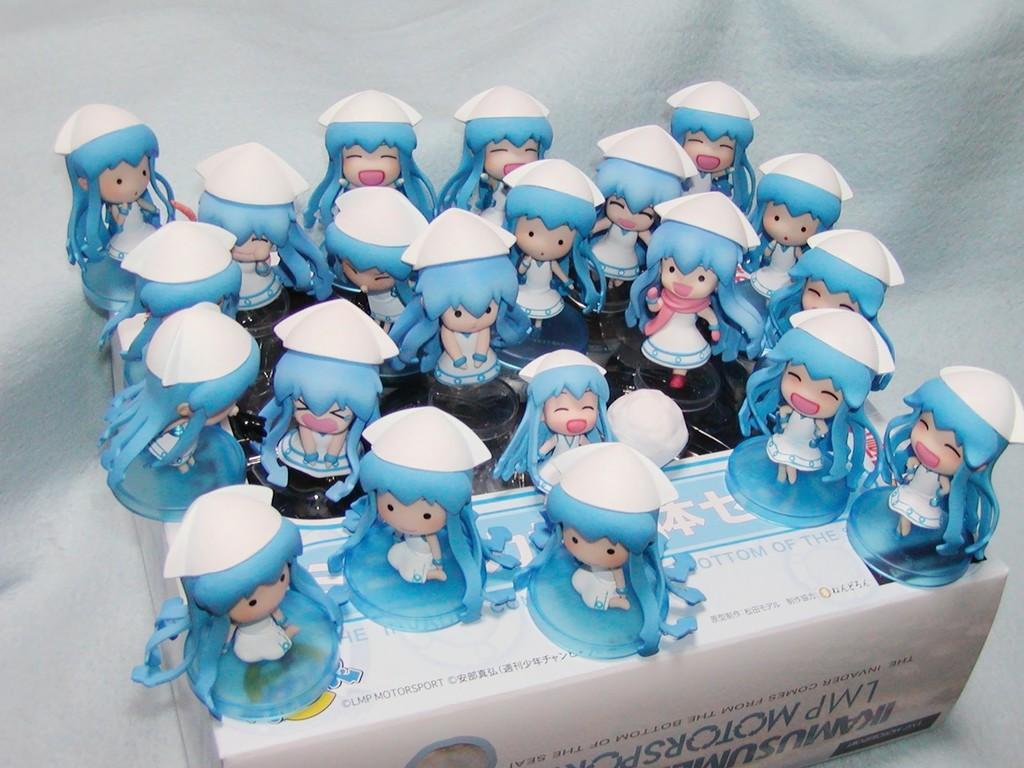How would you summarize this image in a sentence or two? This image consists of toys on a box and a colored background. This image taken, maybe in a house. 